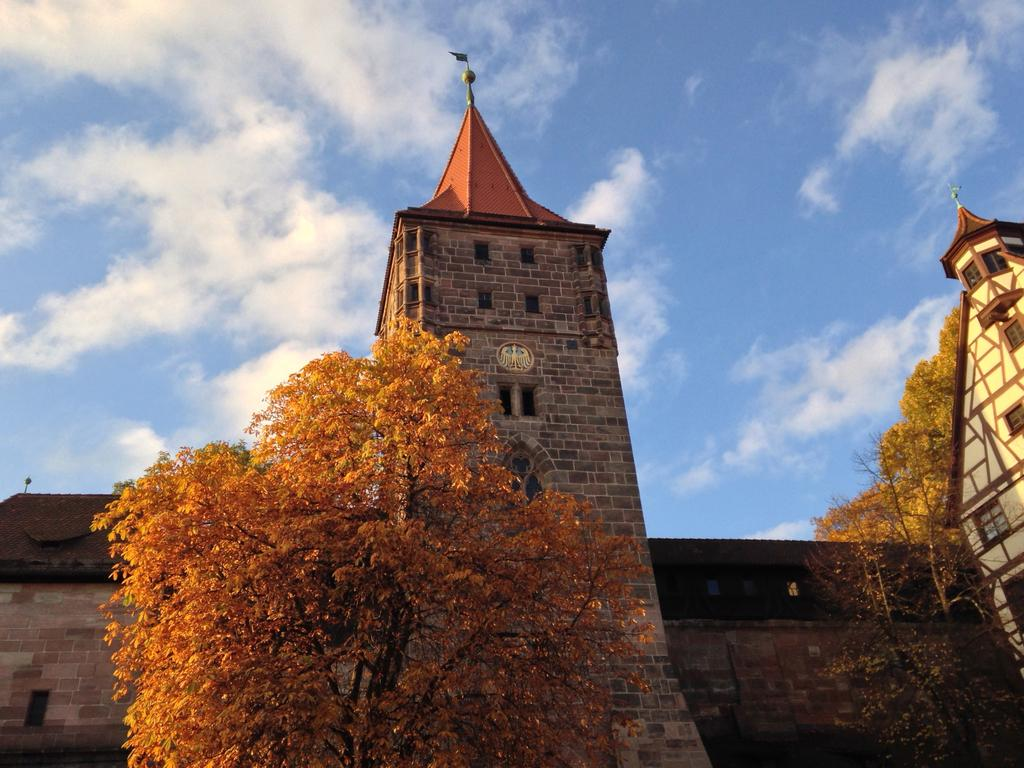What type of structures can be seen in the image? There are buildings and towers in the image. What other natural elements are present in the image? There are trees in the image. What is visible at the top of the image? The sky is visible at the top of the image. What type of punishment is being carried out on the donkey in the image? There is no donkey present in the image, so no punishment can be observed. 